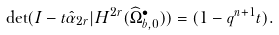<formula> <loc_0><loc_0><loc_500><loc_500>\det ( I - t \hat { \alpha } _ { 2 r } | H ^ { 2 r } ( \widehat { \Omega } ^ { \bullet } _ { b , 0 } ) ) = ( 1 - q ^ { n + 1 } t ) .</formula> 